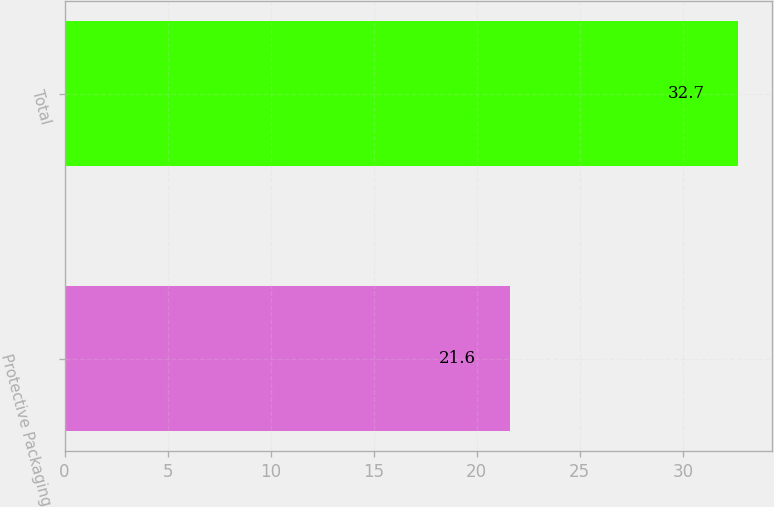Convert chart to OTSL. <chart><loc_0><loc_0><loc_500><loc_500><bar_chart><fcel>Protective Packaging<fcel>Total<nl><fcel>21.6<fcel>32.7<nl></chart> 